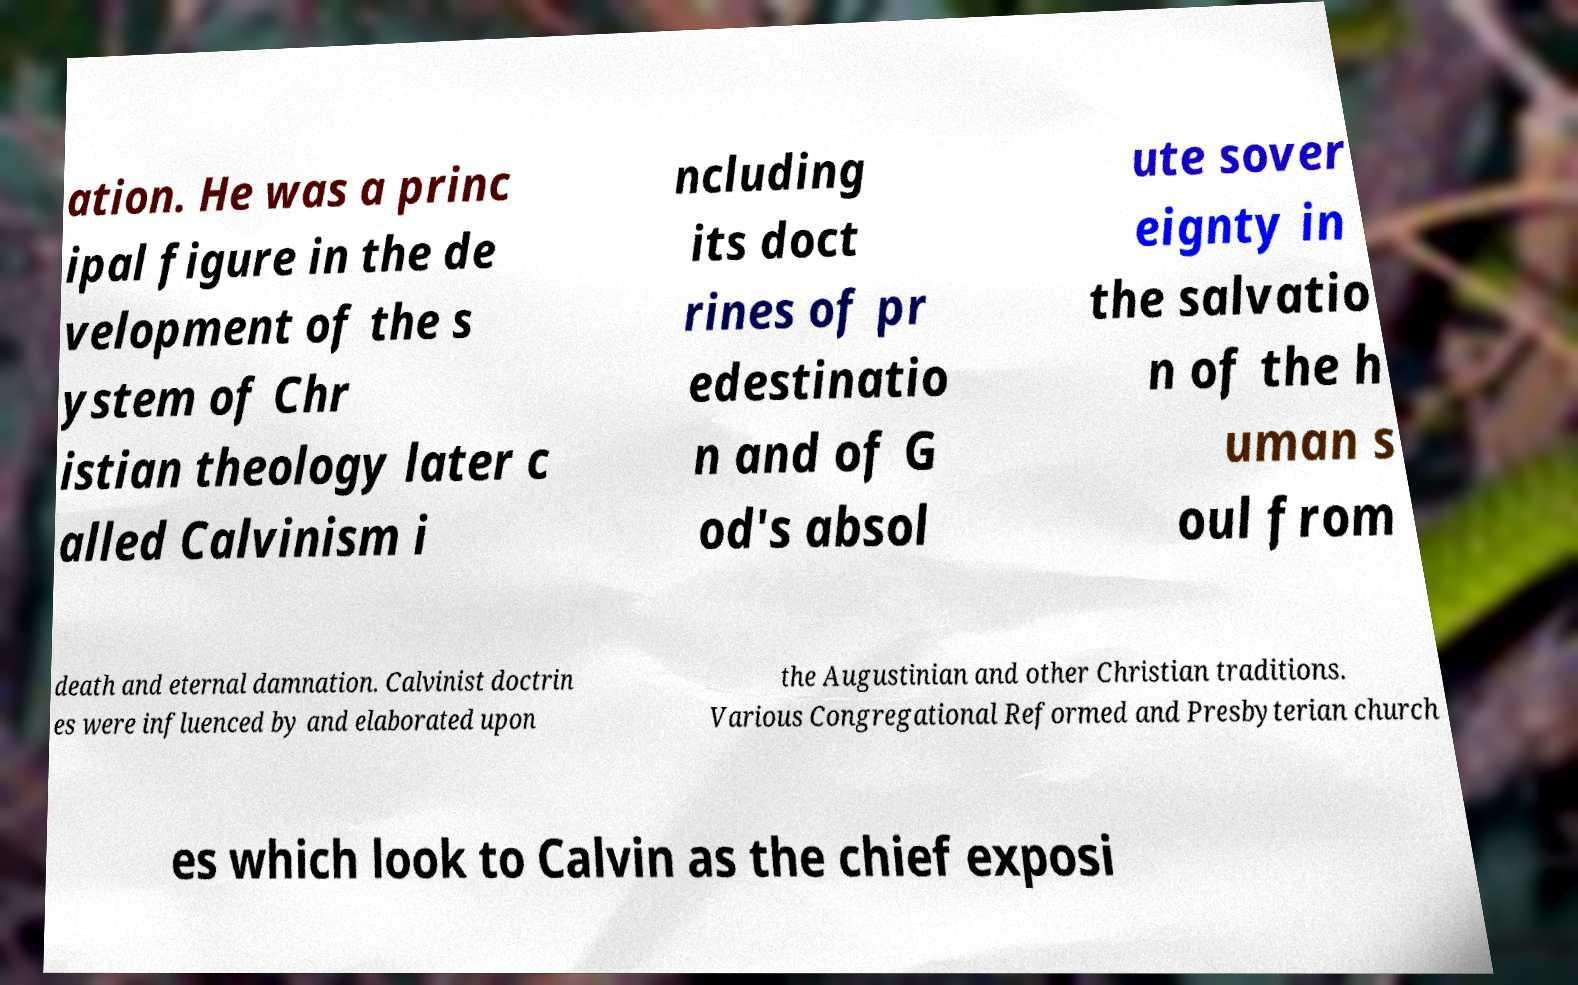What messages or text are displayed in this image? I need them in a readable, typed format. ation. He was a princ ipal figure in the de velopment of the s ystem of Chr istian theology later c alled Calvinism i ncluding its doct rines of pr edestinatio n and of G od's absol ute sover eignty in the salvatio n of the h uman s oul from death and eternal damnation. Calvinist doctrin es were influenced by and elaborated upon the Augustinian and other Christian traditions. Various Congregational Reformed and Presbyterian church es which look to Calvin as the chief exposi 